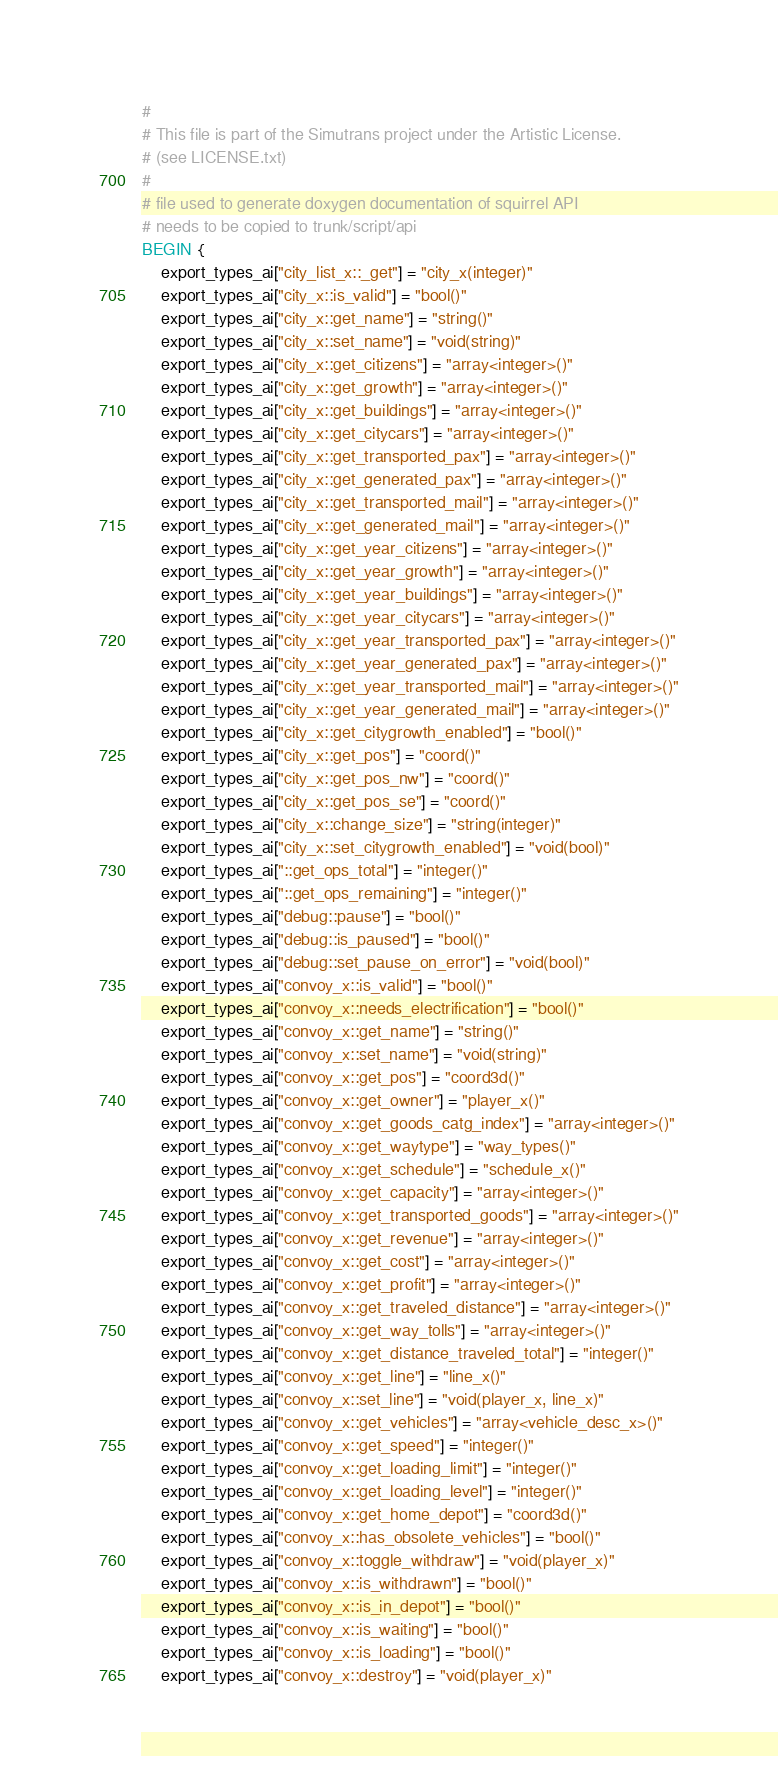Convert code to text. <code><loc_0><loc_0><loc_500><loc_500><_Awk_>#
# This file is part of the Simutrans project under the Artistic License.
# (see LICENSE.txt)
#
# file used to generate doxygen documentation of squirrel API
# needs to be copied to trunk/script/api
BEGIN {
	export_types_ai["city_list_x::_get"] = "city_x(integer)"
	export_types_ai["city_x::is_valid"] = "bool()"
	export_types_ai["city_x::get_name"] = "string()"
	export_types_ai["city_x::set_name"] = "void(string)"
	export_types_ai["city_x::get_citizens"] = "array<integer>()"
	export_types_ai["city_x::get_growth"] = "array<integer>()"
	export_types_ai["city_x::get_buildings"] = "array<integer>()"
	export_types_ai["city_x::get_citycars"] = "array<integer>()"
	export_types_ai["city_x::get_transported_pax"] = "array<integer>()"
	export_types_ai["city_x::get_generated_pax"] = "array<integer>()"
	export_types_ai["city_x::get_transported_mail"] = "array<integer>()"
	export_types_ai["city_x::get_generated_mail"] = "array<integer>()"
	export_types_ai["city_x::get_year_citizens"] = "array<integer>()"
	export_types_ai["city_x::get_year_growth"] = "array<integer>()"
	export_types_ai["city_x::get_year_buildings"] = "array<integer>()"
	export_types_ai["city_x::get_year_citycars"] = "array<integer>()"
	export_types_ai["city_x::get_year_transported_pax"] = "array<integer>()"
	export_types_ai["city_x::get_year_generated_pax"] = "array<integer>()"
	export_types_ai["city_x::get_year_transported_mail"] = "array<integer>()"
	export_types_ai["city_x::get_year_generated_mail"] = "array<integer>()"
	export_types_ai["city_x::get_citygrowth_enabled"] = "bool()"
	export_types_ai["city_x::get_pos"] = "coord()"
	export_types_ai["city_x::get_pos_nw"] = "coord()"
	export_types_ai["city_x::get_pos_se"] = "coord()"
	export_types_ai["city_x::change_size"] = "string(integer)"
	export_types_ai["city_x::set_citygrowth_enabled"] = "void(bool)"
	export_types_ai["::get_ops_total"] = "integer()"
	export_types_ai["::get_ops_remaining"] = "integer()"
	export_types_ai["debug::pause"] = "bool()"
	export_types_ai["debug::is_paused"] = "bool()"
	export_types_ai["debug::set_pause_on_error"] = "void(bool)"
	export_types_ai["convoy_x::is_valid"] = "bool()"
	export_types_ai["convoy_x::needs_electrification"] = "bool()"
	export_types_ai["convoy_x::get_name"] = "string()"
	export_types_ai["convoy_x::set_name"] = "void(string)"
	export_types_ai["convoy_x::get_pos"] = "coord3d()"
	export_types_ai["convoy_x::get_owner"] = "player_x()"
	export_types_ai["convoy_x::get_goods_catg_index"] = "array<integer>()"
	export_types_ai["convoy_x::get_waytype"] = "way_types()"
	export_types_ai["convoy_x::get_schedule"] = "schedule_x()"
	export_types_ai["convoy_x::get_capacity"] = "array<integer>()"
	export_types_ai["convoy_x::get_transported_goods"] = "array<integer>()"
	export_types_ai["convoy_x::get_revenue"] = "array<integer>()"
	export_types_ai["convoy_x::get_cost"] = "array<integer>()"
	export_types_ai["convoy_x::get_profit"] = "array<integer>()"
	export_types_ai["convoy_x::get_traveled_distance"] = "array<integer>()"
	export_types_ai["convoy_x::get_way_tolls"] = "array<integer>()"
	export_types_ai["convoy_x::get_distance_traveled_total"] = "integer()"
	export_types_ai["convoy_x::get_line"] = "line_x()"
	export_types_ai["convoy_x::set_line"] = "void(player_x, line_x)"
	export_types_ai["convoy_x::get_vehicles"] = "array<vehicle_desc_x>()"
	export_types_ai["convoy_x::get_speed"] = "integer()"
	export_types_ai["convoy_x::get_loading_limit"] = "integer()"
	export_types_ai["convoy_x::get_loading_level"] = "integer()"
	export_types_ai["convoy_x::get_home_depot"] = "coord3d()"
	export_types_ai["convoy_x::has_obsolete_vehicles"] = "bool()"
	export_types_ai["convoy_x::toggle_withdraw"] = "void(player_x)"
	export_types_ai["convoy_x::is_withdrawn"] = "bool()"
	export_types_ai["convoy_x::is_in_depot"] = "bool()"
	export_types_ai["convoy_x::is_waiting"] = "bool()"
	export_types_ai["convoy_x::is_loading"] = "bool()"
	export_types_ai["convoy_x::destroy"] = "void(player_x)"</code> 